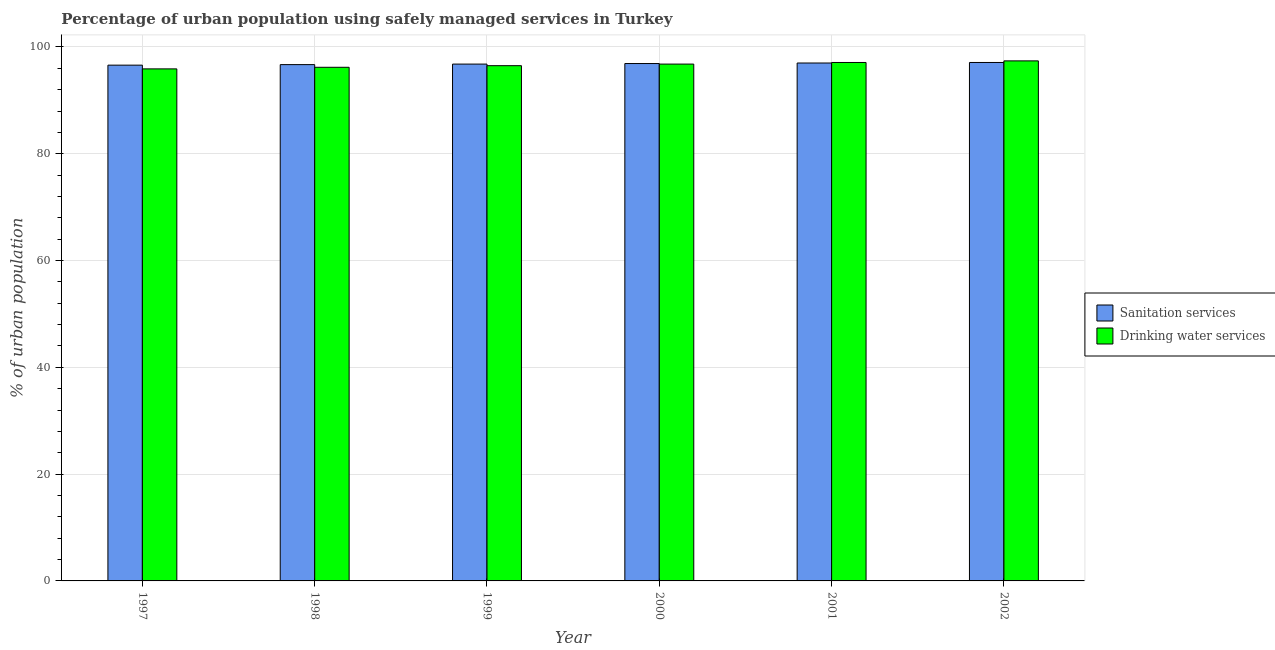How many different coloured bars are there?
Keep it short and to the point. 2. Are the number of bars per tick equal to the number of legend labels?
Provide a short and direct response. Yes. Are the number of bars on each tick of the X-axis equal?
Provide a short and direct response. Yes. How many bars are there on the 3rd tick from the left?
Your response must be concise. 2. In how many cases, is the number of bars for a given year not equal to the number of legend labels?
Your answer should be compact. 0. What is the percentage of urban population who used sanitation services in 1997?
Give a very brief answer. 96.6. Across all years, what is the maximum percentage of urban population who used drinking water services?
Your answer should be compact. 97.4. Across all years, what is the minimum percentage of urban population who used sanitation services?
Ensure brevity in your answer.  96.6. What is the total percentage of urban population who used drinking water services in the graph?
Keep it short and to the point. 579.9. What is the difference between the percentage of urban population who used sanitation services in 1997 and that in 2000?
Give a very brief answer. -0.3. What is the difference between the percentage of urban population who used sanitation services in 1999 and the percentage of urban population who used drinking water services in 2002?
Keep it short and to the point. -0.3. What is the average percentage of urban population who used drinking water services per year?
Give a very brief answer. 96.65. In how many years, is the percentage of urban population who used sanitation services greater than 24 %?
Make the answer very short. 6. What is the ratio of the percentage of urban population who used sanitation services in 1999 to that in 2002?
Ensure brevity in your answer.  1. Is the difference between the percentage of urban population who used sanitation services in 1998 and 2002 greater than the difference between the percentage of urban population who used drinking water services in 1998 and 2002?
Provide a succinct answer. No. What is the difference between the highest and the second highest percentage of urban population who used sanitation services?
Give a very brief answer. 0.1. What is the difference between the highest and the lowest percentage of urban population who used drinking water services?
Ensure brevity in your answer.  1.5. In how many years, is the percentage of urban population who used sanitation services greater than the average percentage of urban population who used sanitation services taken over all years?
Your answer should be very brief. 3. What does the 1st bar from the left in 1999 represents?
Give a very brief answer. Sanitation services. What does the 1st bar from the right in 1999 represents?
Ensure brevity in your answer.  Drinking water services. How many bars are there?
Offer a terse response. 12. Are all the bars in the graph horizontal?
Offer a very short reply. No. What is the difference between two consecutive major ticks on the Y-axis?
Provide a succinct answer. 20. Where does the legend appear in the graph?
Keep it short and to the point. Center right. How many legend labels are there?
Provide a succinct answer. 2. How are the legend labels stacked?
Your answer should be very brief. Vertical. What is the title of the graph?
Your answer should be compact. Percentage of urban population using safely managed services in Turkey. What is the label or title of the X-axis?
Ensure brevity in your answer.  Year. What is the label or title of the Y-axis?
Make the answer very short. % of urban population. What is the % of urban population in Sanitation services in 1997?
Provide a short and direct response. 96.6. What is the % of urban population in Drinking water services in 1997?
Provide a short and direct response. 95.9. What is the % of urban population of Sanitation services in 1998?
Offer a terse response. 96.7. What is the % of urban population in Drinking water services in 1998?
Offer a very short reply. 96.2. What is the % of urban population of Sanitation services in 1999?
Make the answer very short. 96.8. What is the % of urban population of Drinking water services in 1999?
Your answer should be very brief. 96.5. What is the % of urban population of Sanitation services in 2000?
Provide a succinct answer. 96.9. What is the % of urban population in Drinking water services in 2000?
Your answer should be very brief. 96.8. What is the % of urban population in Sanitation services in 2001?
Keep it short and to the point. 97. What is the % of urban population of Drinking water services in 2001?
Offer a terse response. 97.1. What is the % of urban population of Sanitation services in 2002?
Make the answer very short. 97.1. What is the % of urban population of Drinking water services in 2002?
Provide a succinct answer. 97.4. Across all years, what is the maximum % of urban population in Sanitation services?
Offer a terse response. 97.1. Across all years, what is the maximum % of urban population in Drinking water services?
Make the answer very short. 97.4. Across all years, what is the minimum % of urban population of Sanitation services?
Offer a terse response. 96.6. Across all years, what is the minimum % of urban population in Drinking water services?
Make the answer very short. 95.9. What is the total % of urban population of Sanitation services in the graph?
Offer a terse response. 581.1. What is the total % of urban population of Drinking water services in the graph?
Make the answer very short. 579.9. What is the difference between the % of urban population in Sanitation services in 1997 and that in 1998?
Offer a very short reply. -0.1. What is the difference between the % of urban population in Drinking water services in 1997 and that in 1998?
Make the answer very short. -0.3. What is the difference between the % of urban population of Sanitation services in 1997 and that in 1999?
Your response must be concise. -0.2. What is the difference between the % of urban population in Sanitation services in 1997 and that in 2000?
Offer a terse response. -0.3. What is the difference between the % of urban population in Drinking water services in 1997 and that in 2001?
Your response must be concise. -1.2. What is the difference between the % of urban population of Drinking water services in 1998 and that in 1999?
Your answer should be compact. -0.3. What is the difference between the % of urban population of Sanitation services in 1998 and that in 2001?
Provide a succinct answer. -0.3. What is the difference between the % of urban population in Drinking water services in 1998 and that in 2002?
Your answer should be compact. -1.2. What is the difference between the % of urban population in Sanitation services in 1999 and that in 2000?
Ensure brevity in your answer.  -0.1. What is the difference between the % of urban population in Drinking water services in 1999 and that in 2000?
Make the answer very short. -0.3. What is the difference between the % of urban population in Drinking water services in 1999 and that in 2001?
Your answer should be compact. -0.6. What is the difference between the % of urban population of Sanitation services in 1999 and that in 2002?
Your answer should be compact. -0.3. What is the difference between the % of urban population of Drinking water services in 1999 and that in 2002?
Your response must be concise. -0.9. What is the difference between the % of urban population of Sanitation services in 2000 and that in 2001?
Offer a very short reply. -0.1. What is the difference between the % of urban population of Sanitation services in 2000 and that in 2002?
Provide a short and direct response. -0.2. What is the difference between the % of urban population of Drinking water services in 2000 and that in 2002?
Offer a very short reply. -0.6. What is the difference between the % of urban population in Drinking water services in 2001 and that in 2002?
Provide a succinct answer. -0.3. What is the difference between the % of urban population of Sanitation services in 1997 and the % of urban population of Drinking water services in 1998?
Your answer should be compact. 0.4. What is the difference between the % of urban population of Sanitation services in 1997 and the % of urban population of Drinking water services in 2000?
Your answer should be very brief. -0.2. What is the difference between the % of urban population of Sanitation services in 1997 and the % of urban population of Drinking water services in 2001?
Keep it short and to the point. -0.5. What is the difference between the % of urban population of Sanitation services in 1997 and the % of urban population of Drinking water services in 2002?
Your answer should be very brief. -0.8. What is the difference between the % of urban population of Sanitation services in 1999 and the % of urban population of Drinking water services in 2000?
Give a very brief answer. 0. What is the difference between the % of urban population in Sanitation services in 1999 and the % of urban population in Drinking water services in 2001?
Provide a short and direct response. -0.3. What is the difference between the % of urban population in Sanitation services in 1999 and the % of urban population in Drinking water services in 2002?
Your answer should be compact. -0.6. What is the difference between the % of urban population in Sanitation services in 2000 and the % of urban population in Drinking water services in 2001?
Offer a very short reply. -0.2. What is the difference between the % of urban population of Sanitation services in 2000 and the % of urban population of Drinking water services in 2002?
Give a very brief answer. -0.5. What is the difference between the % of urban population of Sanitation services in 2001 and the % of urban population of Drinking water services in 2002?
Your answer should be very brief. -0.4. What is the average % of urban population in Sanitation services per year?
Give a very brief answer. 96.85. What is the average % of urban population of Drinking water services per year?
Your answer should be very brief. 96.65. In the year 1998, what is the difference between the % of urban population of Sanitation services and % of urban population of Drinking water services?
Offer a terse response. 0.5. In the year 2000, what is the difference between the % of urban population of Sanitation services and % of urban population of Drinking water services?
Ensure brevity in your answer.  0.1. In the year 2002, what is the difference between the % of urban population of Sanitation services and % of urban population of Drinking water services?
Give a very brief answer. -0.3. What is the ratio of the % of urban population of Drinking water services in 1997 to that in 1998?
Offer a terse response. 1. What is the ratio of the % of urban population of Sanitation services in 1997 to that in 1999?
Keep it short and to the point. 1. What is the ratio of the % of urban population in Drinking water services in 1997 to that in 2000?
Make the answer very short. 0.99. What is the ratio of the % of urban population in Sanitation services in 1997 to that in 2001?
Keep it short and to the point. 1. What is the ratio of the % of urban population in Drinking water services in 1997 to that in 2001?
Your answer should be very brief. 0.99. What is the ratio of the % of urban population of Sanitation services in 1997 to that in 2002?
Your response must be concise. 0.99. What is the ratio of the % of urban population of Drinking water services in 1997 to that in 2002?
Offer a terse response. 0.98. What is the ratio of the % of urban population in Sanitation services in 1998 to that in 1999?
Provide a short and direct response. 1. What is the ratio of the % of urban population of Sanitation services in 1998 to that in 2000?
Your response must be concise. 1. What is the ratio of the % of urban population in Sanitation services in 1998 to that in 2001?
Offer a very short reply. 1. What is the ratio of the % of urban population in Drinking water services in 1998 to that in 2001?
Keep it short and to the point. 0.99. What is the ratio of the % of urban population of Sanitation services in 1998 to that in 2002?
Offer a terse response. 1. What is the ratio of the % of urban population in Drinking water services in 1999 to that in 2000?
Provide a short and direct response. 1. What is the ratio of the % of urban population of Sanitation services in 1999 to that in 2001?
Make the answer very short. 1. What is the ratio of the % of urban population of Drinking water services in 1999 to that in 2001?
Give a very brief answer. 0.99. What is the ratio of the % of urban population of Sanitation services in 2000 to that in 2001?
Offer a terse response. 1. What is the ratio of the % of urban population in Drinking water services in 2000 to that in 2001?
Offer a terse response. 1. What is the ratio of the % of urban population of Sanitation services in 2000 to that in 2002?
Your answer should be compact. 1. What is the ratio of the % of urban population of Drinking water services in 2000 to that in 2002?
Offer a terse response. 0.99. What is the ratio of the % of urban population of Drinking water services in 2001 to that in 2002?
Your answer should be very brief. 1. What is the difference between the highest and the lowest % of urban population in Sanitation services?
Keep it short and to the point. 0.5. What is the difference between the highest and the lowest % of urban population in Drinking water services?
Your response must be concise. 1.5. 